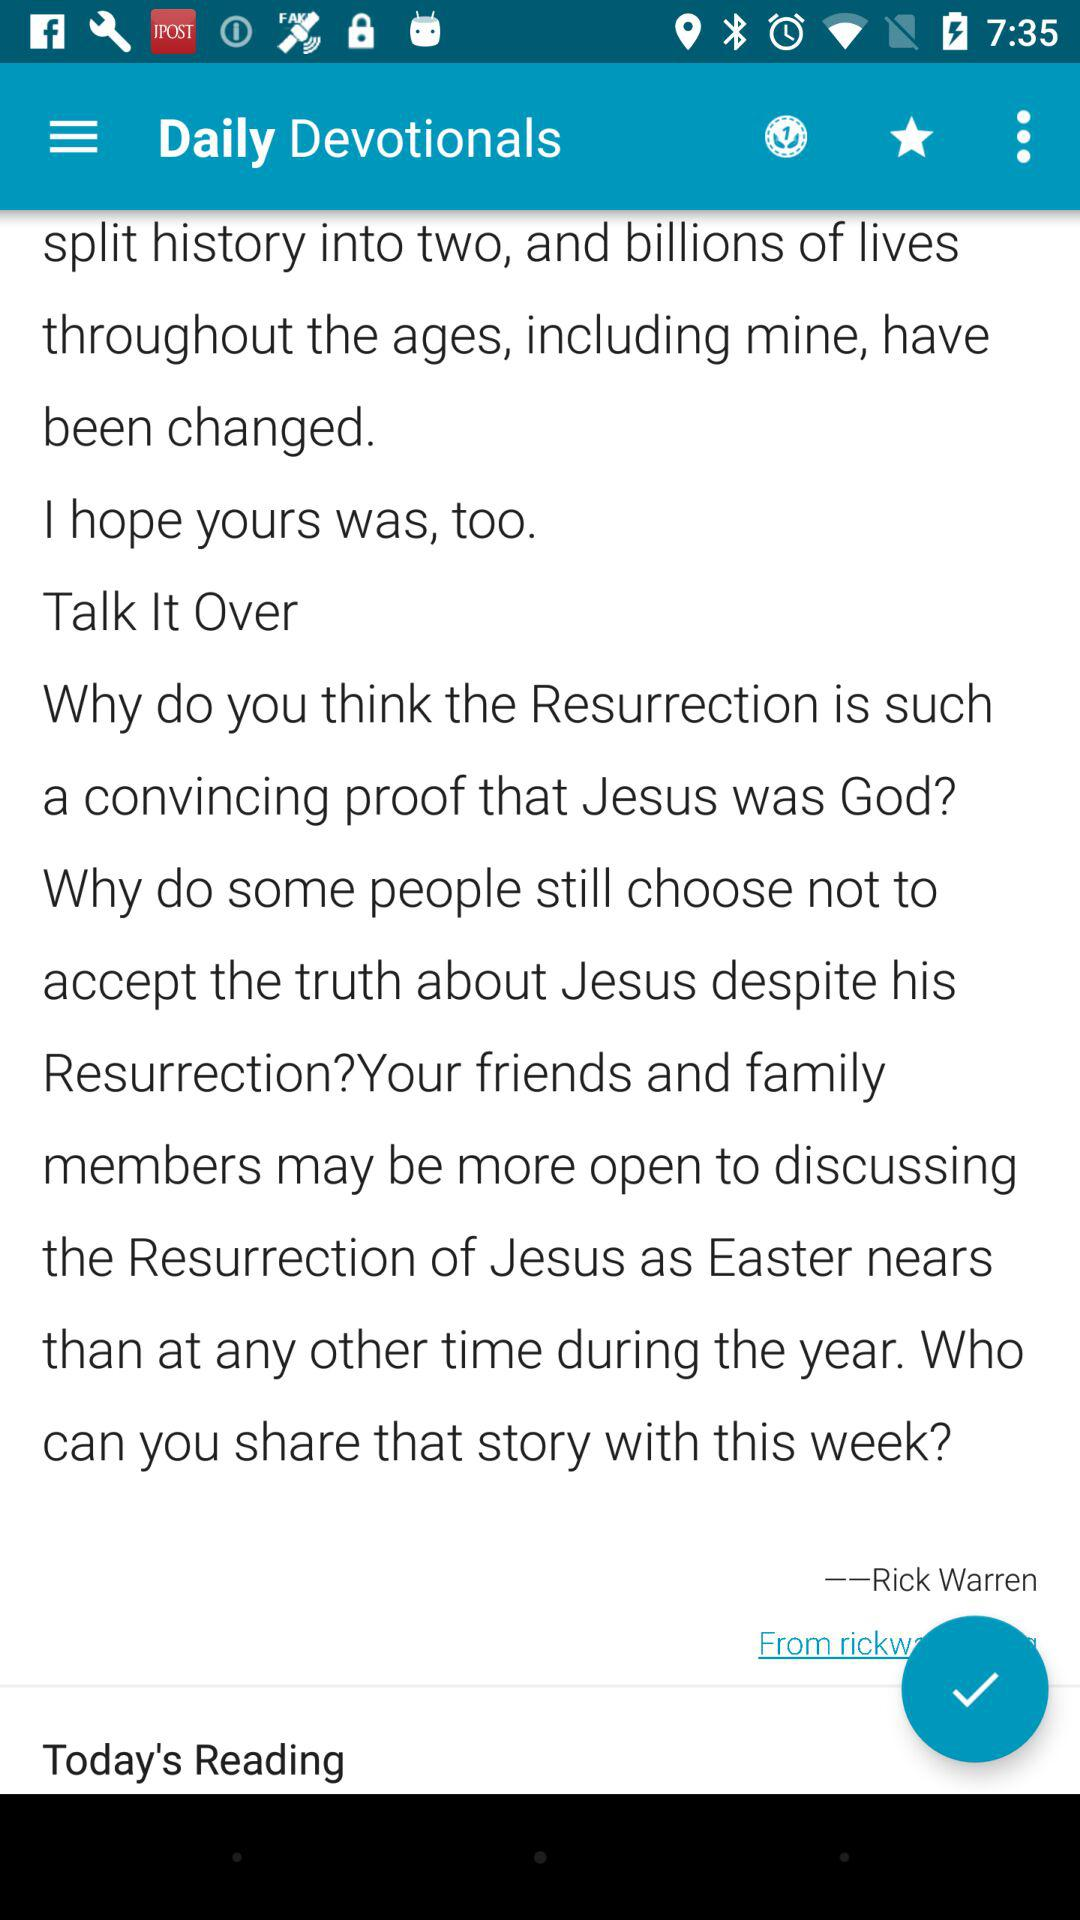What's writer name? The writer name is Rick Warren. 